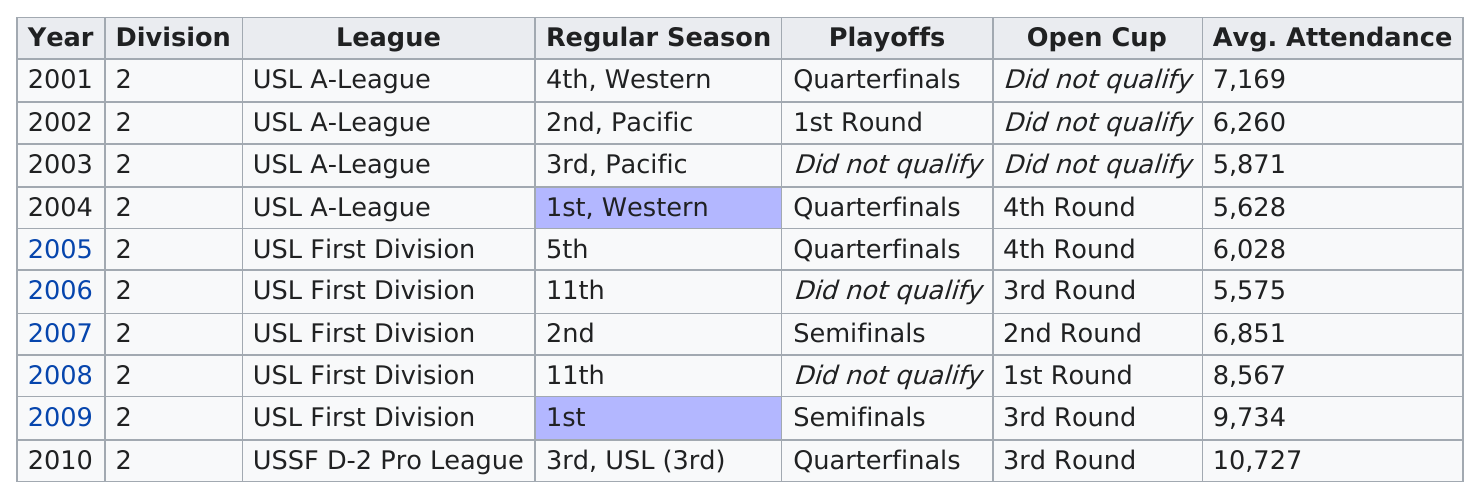Draw attention to some important aspects in this diagram. This team finished in the same position in the Lamar Hunt U.S. Open Cup in 2005 as they did in 2004. In the years where the team did not advance to the quarterfinals, the team did not compete in the USL First Division in 2003. In the years when the team finished lower than second place, the year with the lowest average attendance was 2006. In the one year in which a USL First Division team made the quarter or semi finals and had an average attendance higher than 7,000, which was also the only year in which the team's average attendance was higher than 7,000, the team made the quarter or semi finals of the USL Championship in 2009. The USL A-League reached the quarterfinals two times. 